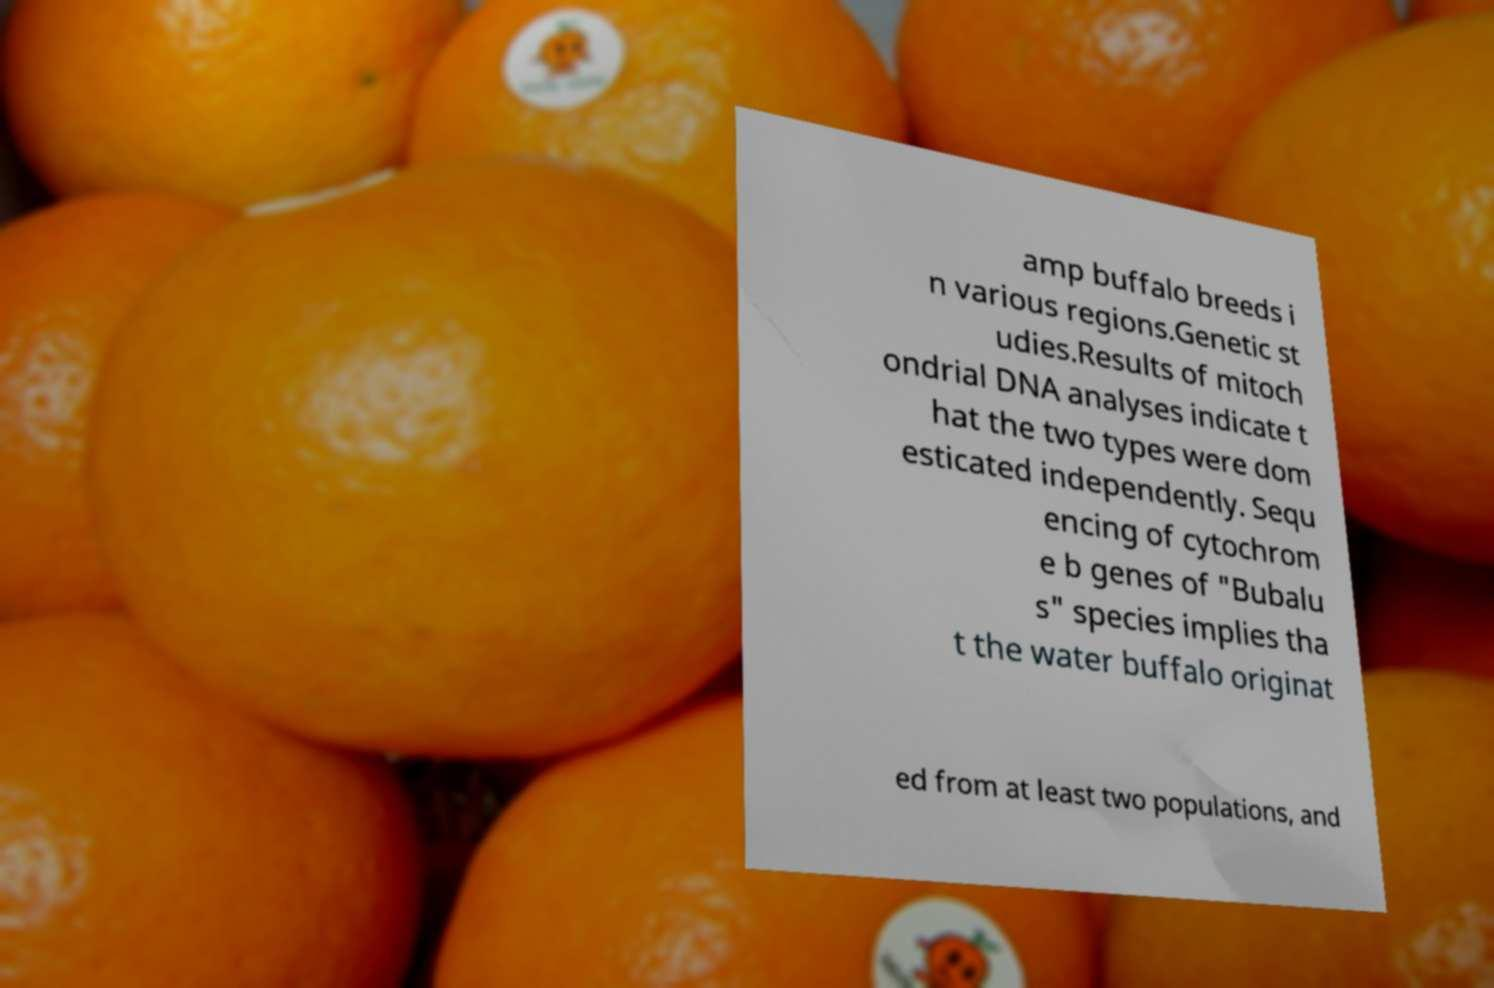Could you assist in decoding the text presented in this image and type it out clearly? amp buffalo breeds i n various regions.Genetic st udies.Results of mitoch ondrial DNA analyses indicate t hat the two types were dom esticated independently. Sequ encing of cytochrom e b genes of "Bubalu s" species implies tha t the water buffalo originat ed from at least two populations, and 